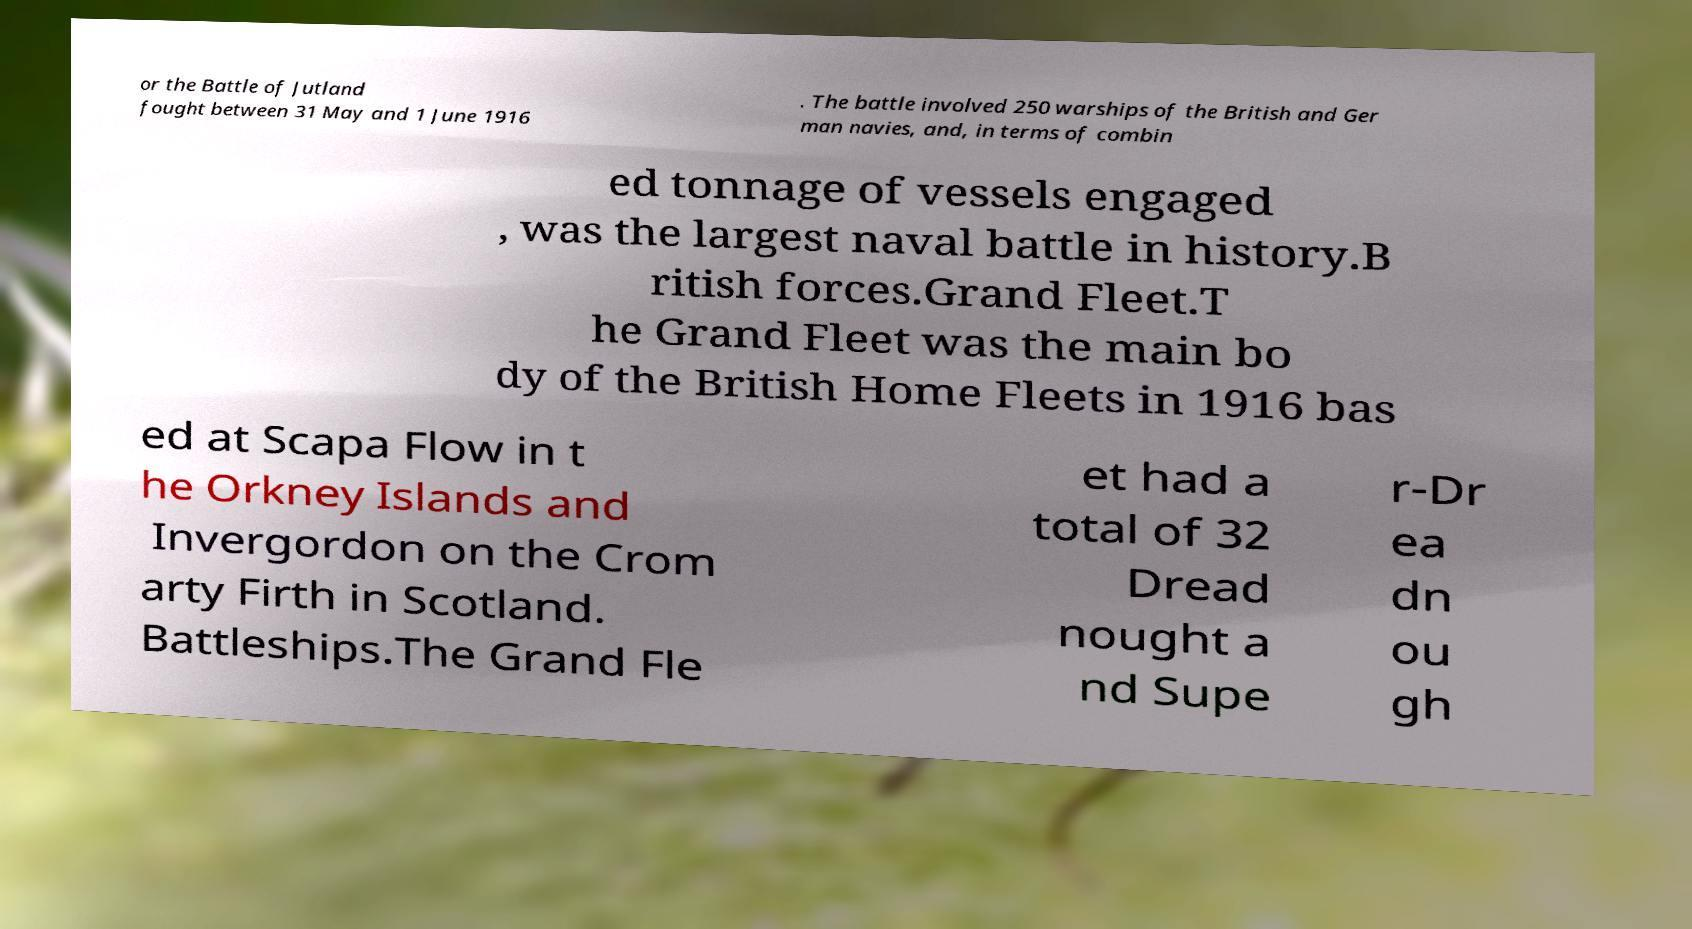There's text embedded in this image that I need extracted. Can you transcribe it verbatim? or the Battle of Jutland fought between 31 May and 1 June 1916 . The battle involved 250 warships of the British and Ger man navies, and, in terms of combin ed tonnage of vessels engaged , was the largest naval battle in history.B ritish forces.Grand Fleet.T he Grand Fleet was the main bo dy of the British Home Fleets in 1916 bas ed at Scapa Flow in t he Orkney Islands and Invergordon on the Crom arty Firth in Scotland. Battleships.The Grand Fle et had a total of 32 Dread nought a nd Supe r-Dr ea dn ou gh 